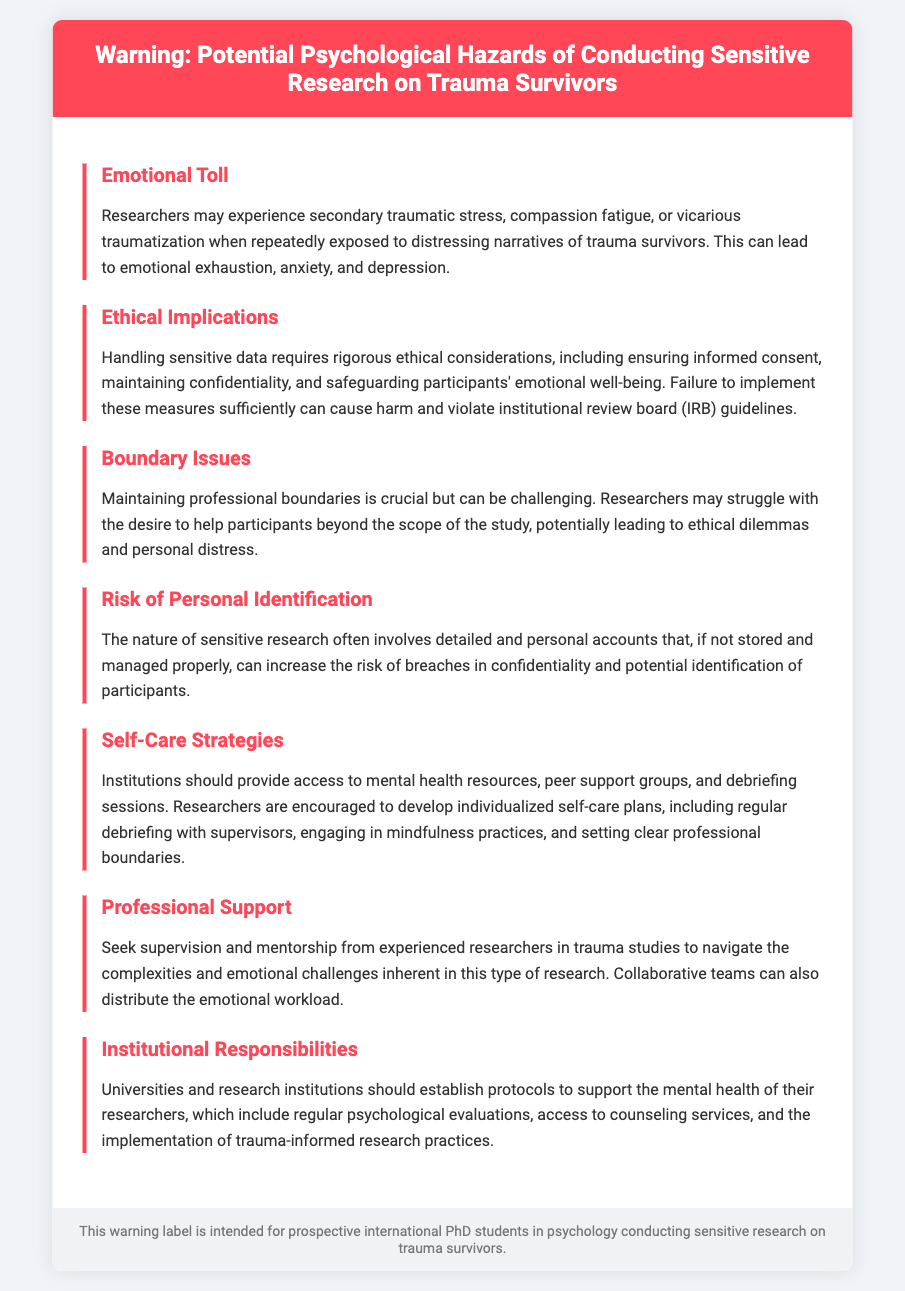What are researchers at risk of experiencing? The document states that researchers may experience secondary traumatic stress, compassion fatigue, or vicarious traumatization.
Answer: Secondary traumatic stress What is a crucial aspect of handling sensitive data? The document emphasizes that handling sensitive data requires rigorous ethical considerations, including informed consent.
Answer: Informed consent What is recommended for researchers to assist their mental health? The document mentions that institutions should provide access to mental health resources.
Answer: Mental health resources What are the professionals encouraged to seek for guidance? Researchers are advised to seek supervision and mentorship from experienced researchers in trauma studies.
Answer: Supervision and mentorship What can institutions implement to support researchers? Establishing protocols to support the mental health of their researchers is suggested in the document.
Answer: Protocols for mental health support 